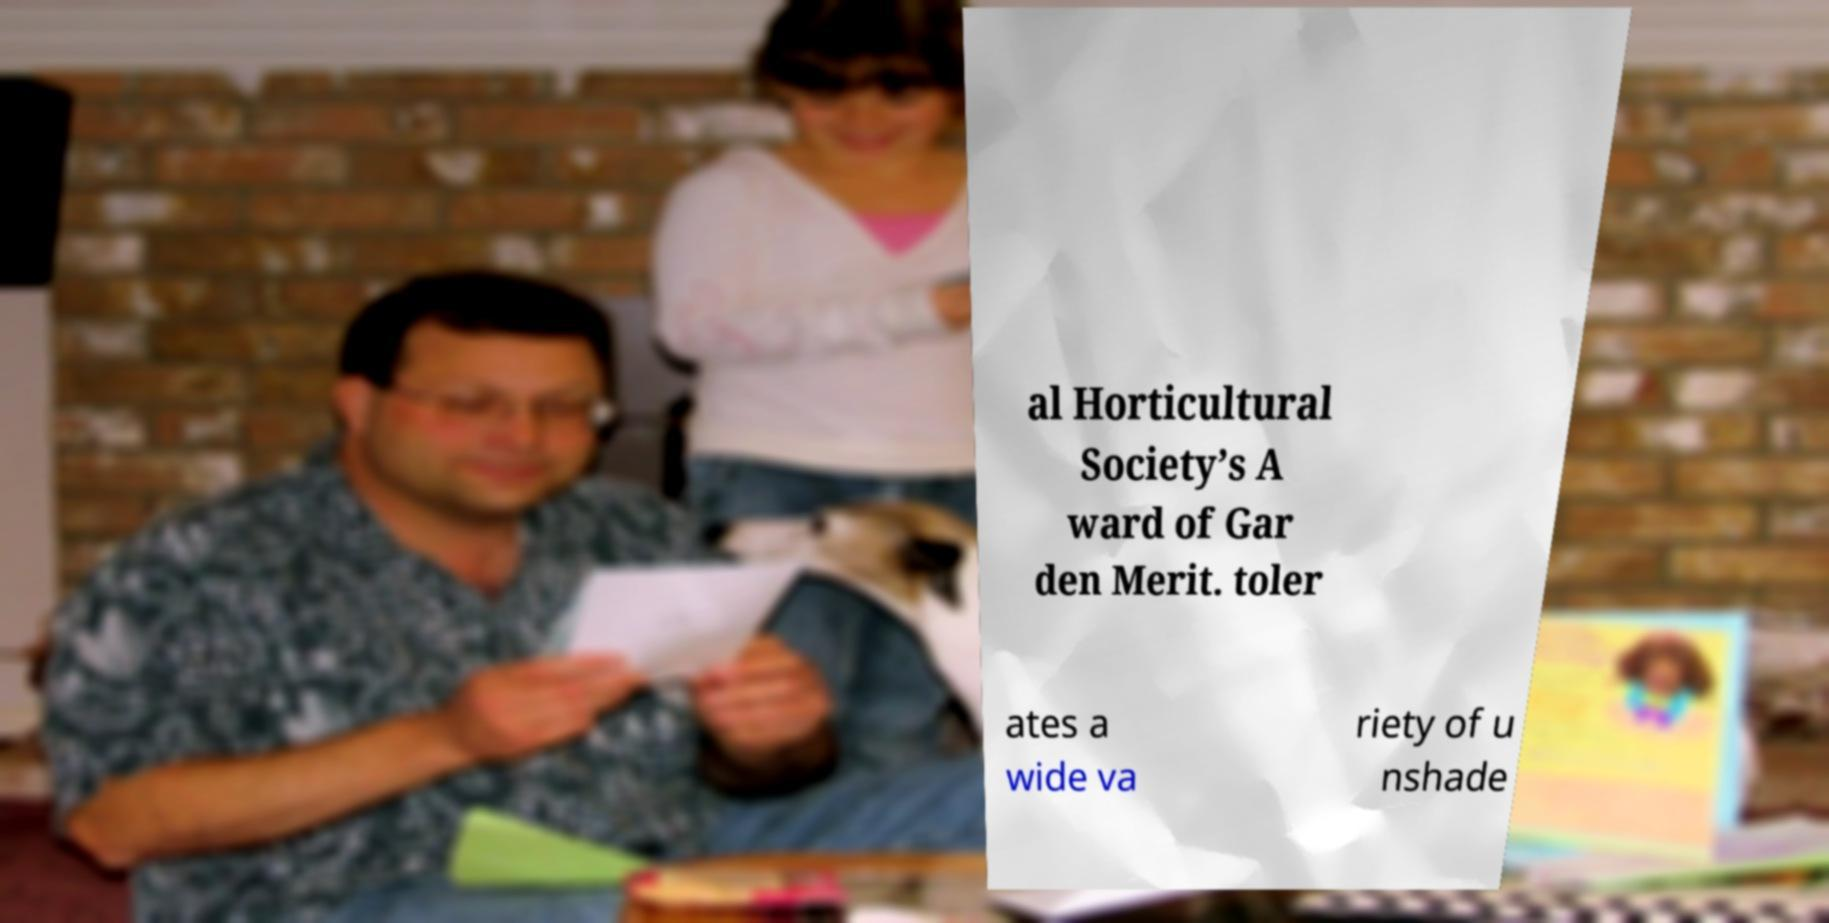Can you read and provide the text displayed in the image?This photo seems to have some interesting text. Can you extract and type it out for me? al Horticultural Society’s A ward of Gar den Merit. toler ates a wide va riety of u nshade 